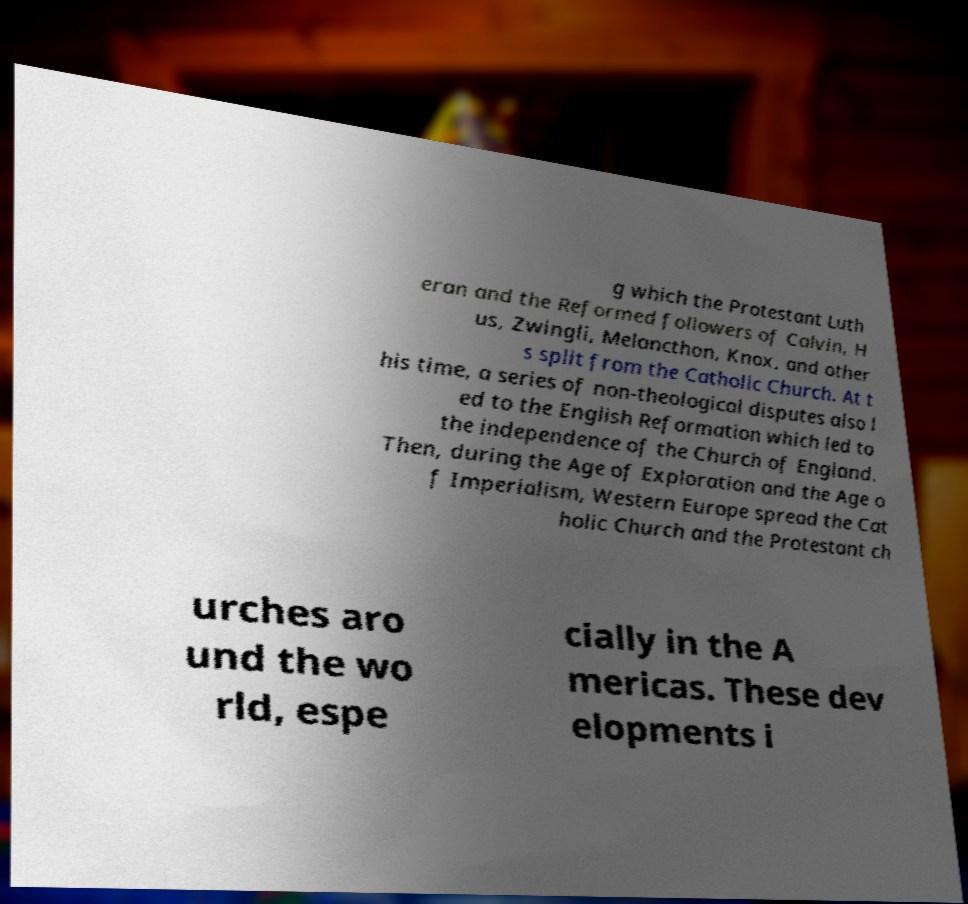For documentation purposes, I need the text within this image transcribed. Could you provide that? g which the Protestant Luth eran and the Reformed followers of Calvin, H us, Zwingli, Melancthon, Knox, and other s split from the Catholic Church. At t his time, a series of non-theological disputes also l ed to the English Reformation which led to the independence of the Church of England. Then, during the Age of Exploration and the Age o f Imperialism, Western Europe spread the Cat holic Church and the Protestant ch urches aro und the wo rld, espe cially in the A mericas. These dev elopments i 